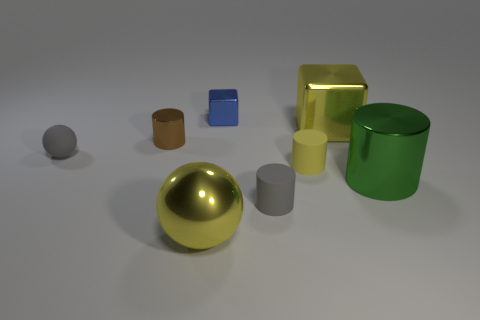Can you describe the texture contrast among the objects? Certainly! The objects exhibit a variety of textures: the shiny objects, such as the golden sphere and blue block, reflect light smoothly and indicate a polished surface, while the green cylinder and grey sphere seem to have a matte finish, diffusing light softly and suggesting a less reflective texture. 